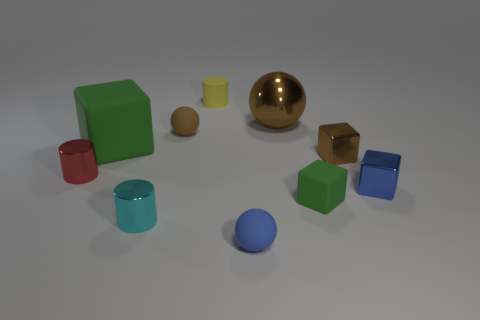Subtract all cylinders. How many objects are left? 7 Subtract 0 purple cylinders. How many objects are left? 10 Subtract all purple cylinders. Subtract all brown shiny spheres. How many objects are left? 9 Add 4 matte blocks. How many matte blocks are left? 6 Add 2 small cyan metal cylinders. How many small cyan metal cylinders exist? 3 